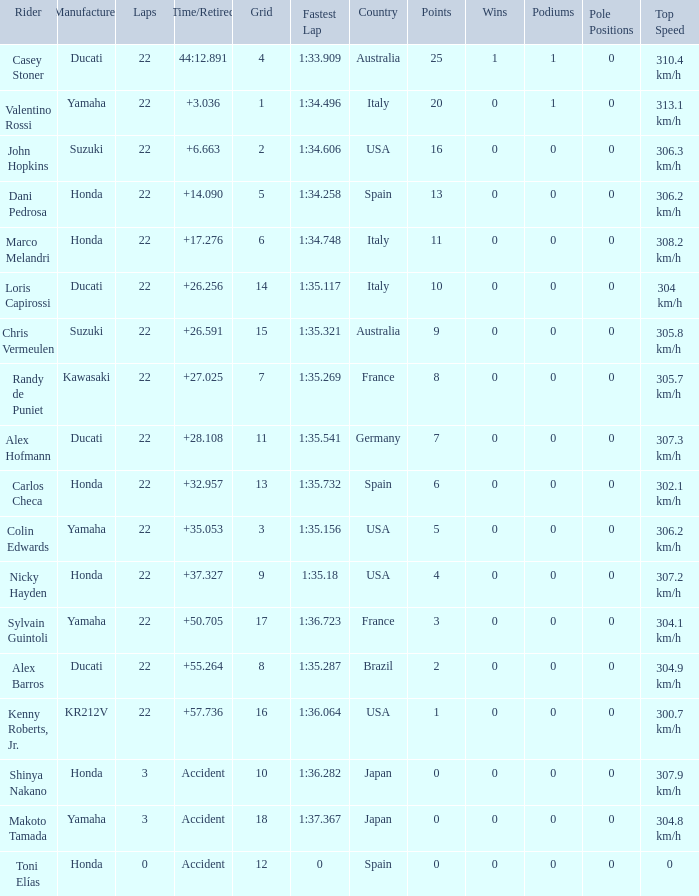What was the average amount of laps for competitors with a grid that was more than 11 and a Time/Retired of +28.108? None. 